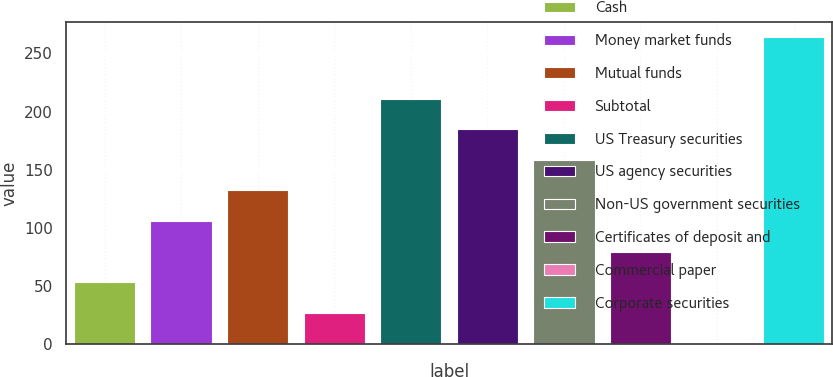<chart> <loc_0><loc_0><loc_500><loc_500><bar_chart><fcel>Cash<fcel>Money market funds<fcel>Mutual funds<fcel>Subtotal<fcel>US Treasury securities<fcel>US agency securities<fcel>Non-US government securities<fcel>Certificates of deposit and<fcel>Commercial paper<fcel>Corporate securities<nl><fcel>52.88<fcel>105.66<fcel>132.05<fcel>26.49<fcel>211.22<fcel>184.83<fcel>158.44<fcel>79.27<fcel>0.1<fcel>264<nl></chart> 